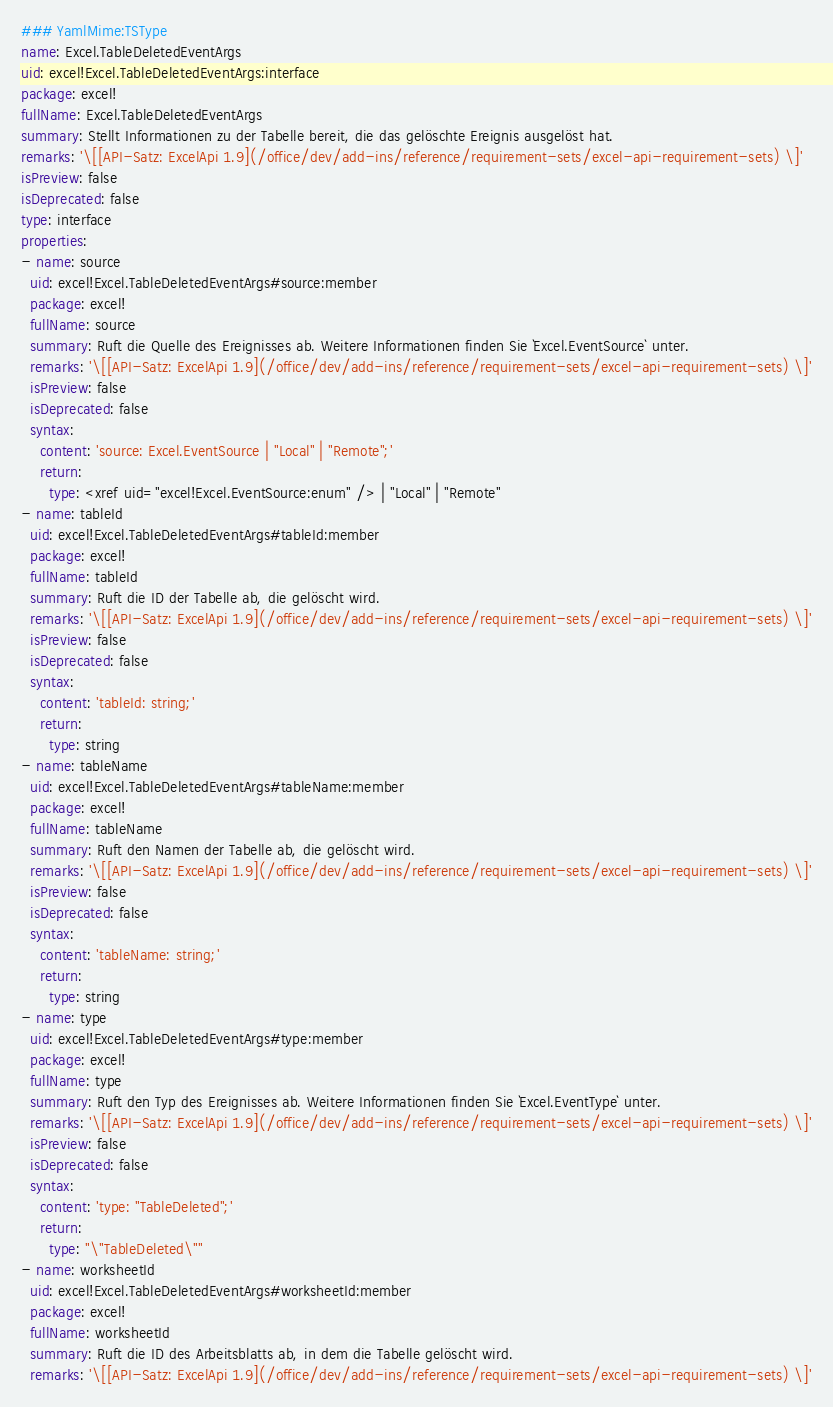<code> <loc_0><loc_0><loc_500><loc_500><_YAML_>### YamlMime:TSType
name: Excel.TableDeletedEventArgs
uid: excel!Excel.TableDeletedEventArgs:interface
package: excel!
fullName: Excel.TableDeletedEventArgs
summary: Stellt Informationen zu der Tabelle bereit, die das gelöschte Ereignis ausgelöst hat.
remarks: '\[[API-Satz: ExcelApi 1.9](/office/dev/add-ins/reference/requirement-sets/excel-api-requirement-sets) \]'
isPreview: false
isDeprecated: false
type: interface
properties:
- name: source
  uid: excel!Excel.TableDeletedEventArgs#source:member
  package: excel!
  fullName: source
  summary: Ruft die Quelle des Ereignisses ab. Weitere Informationen finden Sie `Excel.EventSource` unter.
  remarks: '\[[API-Satz: ExcelApi 1.9](/office/dev/add-ins/reference/requirement-sets/excel-api-requirement-sets) \]'
  isPreview: false
  isDeprecated: false
  syntax:
    content: 'source: Excel.EventSource | "Local" | "Remote";'
    return:
      type: <xref uid="excel!Excel.EventSource:enum" /> | "Local" | "Remote"
- name: tableId
  uid: excel!Excel.TableDeletedEventArgs#tableId:member
  package: excel!
  fullName: tableId
  summary: Ruft die ID der Tabelle ab, die gelöscht wird.
  remarks: '\[[API-Satz: ExcelApi 1.9](/office/dev/add-ins/reference/requirement-sets/excel-api-requirement-sets) \]'
  isPreview: false
  isDeprecated: false
  syntax:
    content: 'tableId: string;'
    return:
      type: string
- name: tableName
  uid: excel!Excel.TableDeletedEventArgs#tableName:member
  package: excel!
  fullName: tableName
  summary: Ruft den Namen der Tabelle ab, die gelöscht wird.
  remarks: '\[[API-Satz: ExcelApi 1.9](/office/dev/add-ins/reference/requirement-sets/excel-api-requirement-sets) \]'
  isPreview: false
  isDeprecated: false
  syntax:
    content: 'tableName: string;'
    return:
      type: string
- name: type
  uid: excel!Excel.TableDeletedEventArgs#type:member
  package: excel!
  fullName: type
  summary: Ruft den Typ des Ereignisses ab. Weitere Informationen finden Sie `Excel.EventType` unter.
  remarks: '\[[API-Satz: ExcelApi 1.9](/office/dev/add-ins/reference/requirement-sets/excel-api-requirement-sets) \]'
  isPreview: false
  isDeprecated: false
  syntax:
    content: 'type: "TableDeleted";'
    return:
      type: "\"TableDeleted\""
- name: worksheetId
  uid: excel!Excel.TableDeletedEventArgs#worksheetId:member
  package: excel!
  fullName: worksheetId
  summary: Ruft die ID des Arbeitsblatts ab, in dem die Tabelle gelöscht wird.
  remarks: '\[[API-Satz: ExcelApi 1.9](/office/dev/add-ins/reference/requirement-sets/excel-api-requirement-sets) \]'</code> 